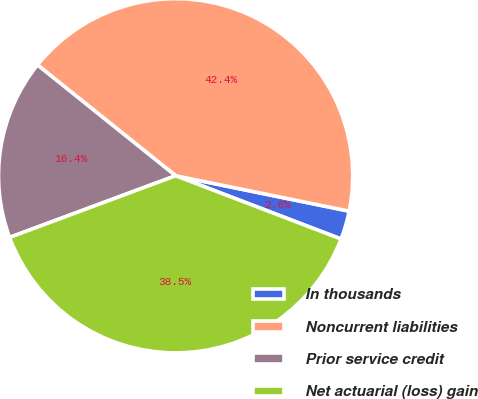<chart> <loc_0><loc_0><loc_500><loc_500><pie_chart><fcel>In thousands<fcel>Noncurrent liabilities<fcel>Prior service credit<fcel>Net actuarial (loss) gain<nl><fcel>2.61%<fcel>42.45%<fcel>16.42%<fcel>38.53%<nl></chart> 